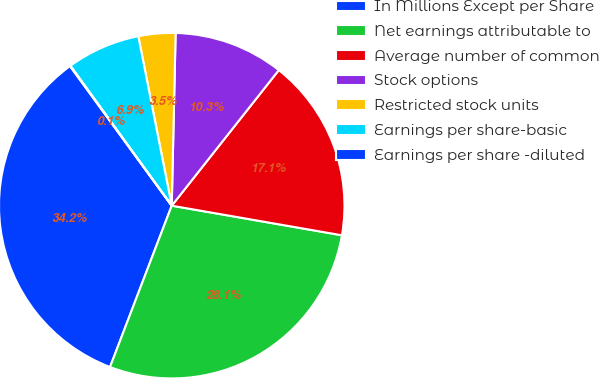<chart> <loc_0><loc_0><loc_500><loc_500><pie_chart><fcel>In Millions Except per Share<fcel>Net earnings attributable to<fcel>Average number of common<fcel>Stock options<fcel>Restricted stock units<fcel>Earnings per share-basic<fcel>Earnings per share -diluted<nl><fcel>34.16%<fcel>28.07%<fcel>17.1%<fcel>10.28%<fcel>3.46%<fcel>6.87%<fcel>0.05%<nl></chart> 